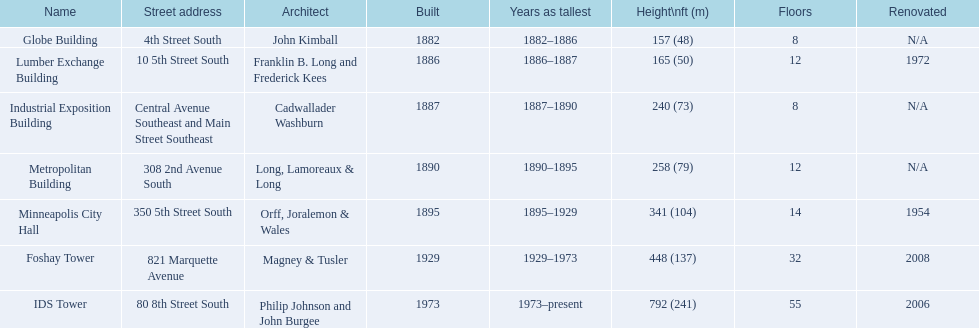Which buildings have the same number of floors as another building? Globe Building, Lumber Exchange Building, Industrial Exposition Building, Metropolitan Building. Of those, which has the same as the lumber exchange building? Metropolitan Building. 